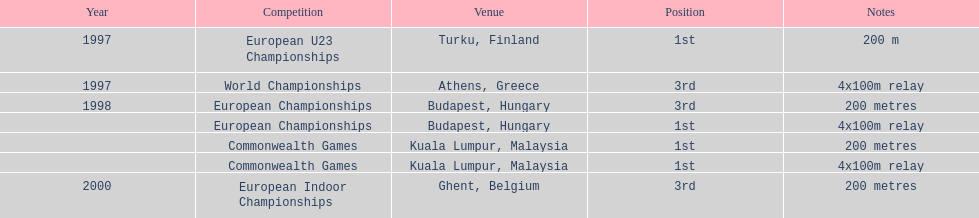How many times were the 4x100m relays raced? 3. 